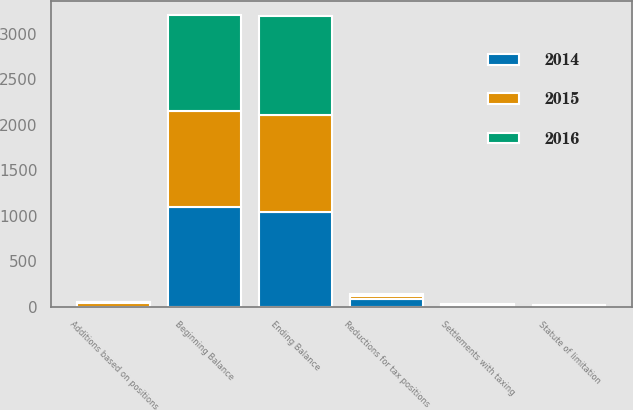<chart> <loc_0><loc_0><loc_500><loc_500><stacked_bar_chart><ecel><fcel>Beginning Balance<fcel>Additions based on positions<fcel>Reductions for tax positions<fcel>Settlements with taxing<fcel>Statute of limitation<fcel>Ending Balance<nl><fcel>2016<fcel>1056<fcel>14<fcel>17<fcel>3<fcel>2<fcel>1095<nl><fcel>2015<fcel>1047<fcel>38<fcel>36<fcel>18<fcel>7<fcel>1056<nl><fcel>2014<fcel>1102<fcel>3<fcel>87<fcel>5<fcel>10<fcel>1047<nl></chart> 